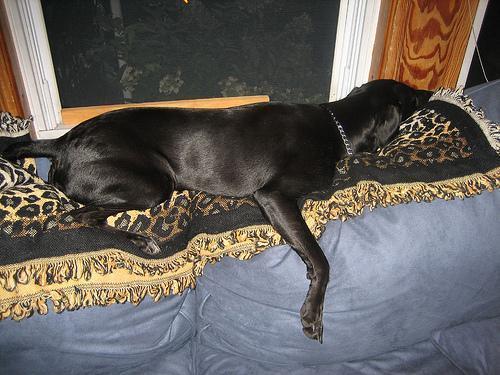How many dogs are there?
Give a very brief answer. 1. 